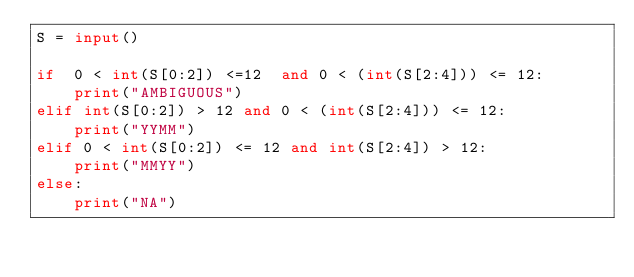<code> <loc_0><loc_0><loc_500><loc_500><_Python_>S = input()

if  0 < int(S[0:2]) <=12  and 0 < (int(S[2:4])) <= 12:
    print("AMBIGUOUS")
elif int(S[0:2]) > 12 and 0 < (int(S[2:4])) <= 12:
    print("YYMM")
elif 0 < int(S[0:2]) <= 12 and int(S[2:4]) > 12:
    print("MMYY")
else:
    print("NA")</code> 